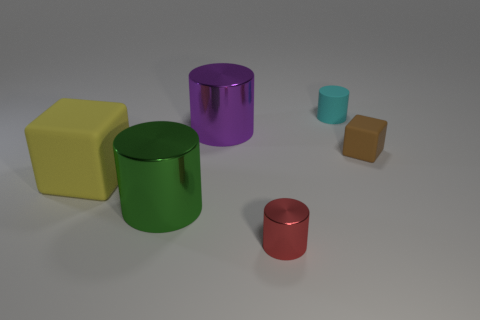Subtract 1 cylinders. How many cylinders are left? 3 Add 2 red shiny objects. How many objects exist? 8 Subtract all cylinders. How many objects are left? 2 Subtract 0 yellow cylinders. How many objects are left? 6 Subtract all red shiny cylinders. Subtract all tiny red shiny cylinders. How many objects are left? 4 Add 2 small red objects. How many small red objects are left? 3 Add 3 large brown matte cylinders. How many large brown matte cylinders exist? 3 